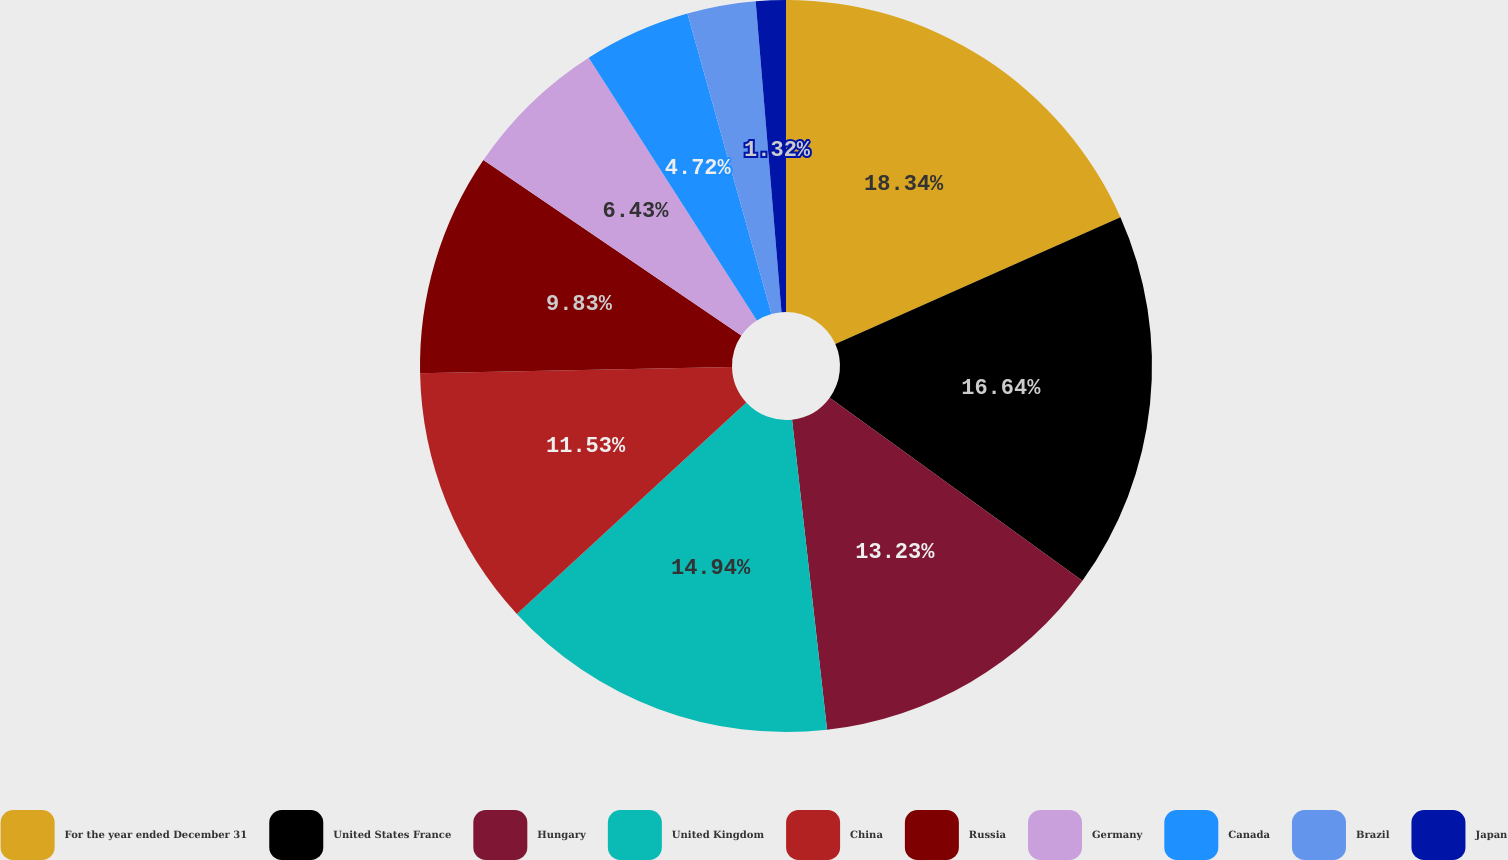Convert chart. <chart><loc_0><loc_0><loc_500><loc_500><pie_chart><fcel>For the year ended December 31<fcel>United States France<fcel>Hungary<fcel>United Kingdom<fcel>China<fcel>Russia<fcel>Germany<fcel>Canada<fcel>Brazil<fcel>Japan<nl><fcel>18.34%<fcel>16.64%<fcel>13.23%<fcel>14.94%<fcel>11.53%<fcel>9.83%<fcel>6.43%<fcel>4.72%<fcel>3.02%<fcel>1.32%<nl></chart> 